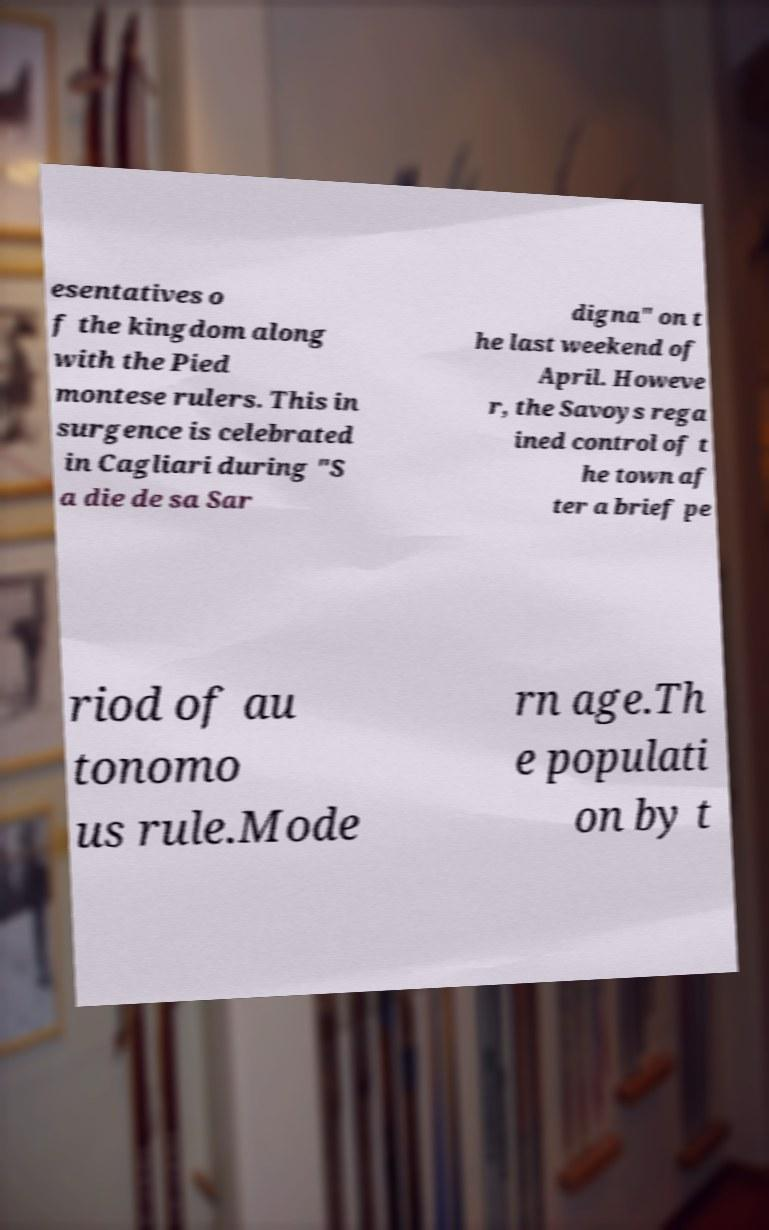For documentation purposes, I need the text within this image transcribed. Could you provide that? esentatives o f the kingdom along with the Pied montese rulers. This in surgence is celebrated in Cagliari during "S a die de sa Sar digna" on t he last weekend of April. Howeve r, the Savoys rega ined control of t he town af ter a brief pe riod of au tonomo us rule.Mode rn age.Th e populati on by t 